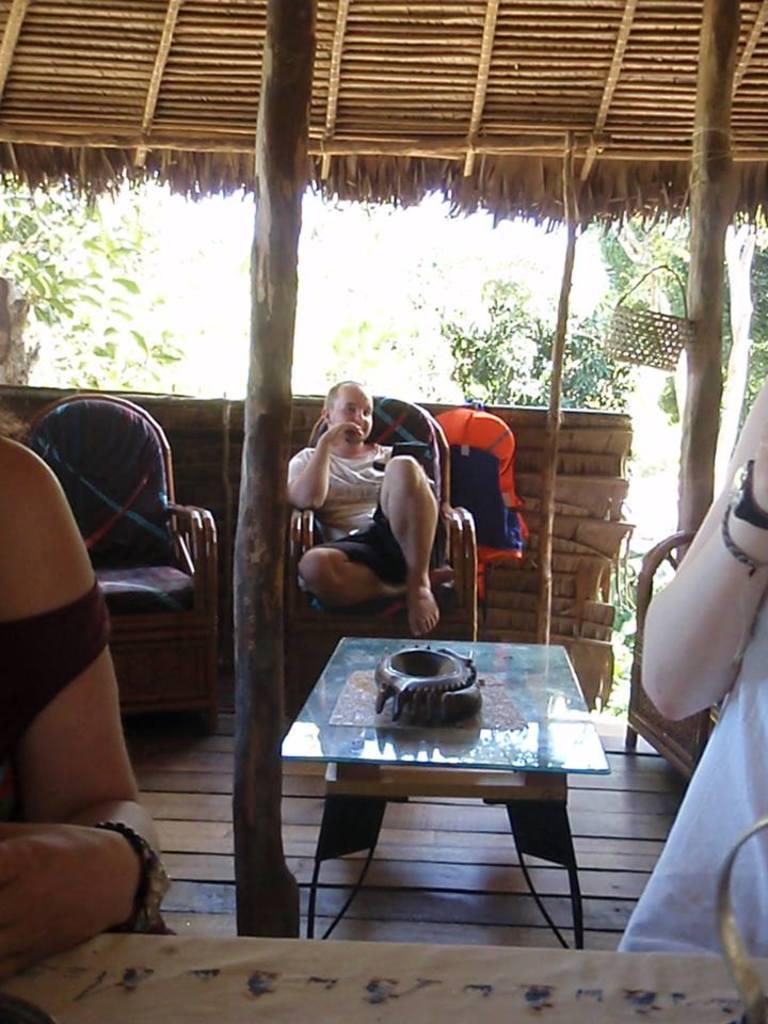In one or two sentences, can you explain what this image depicts? The person is sitting in a chair and there is a table and two persons in front of him, In background there are trees. 